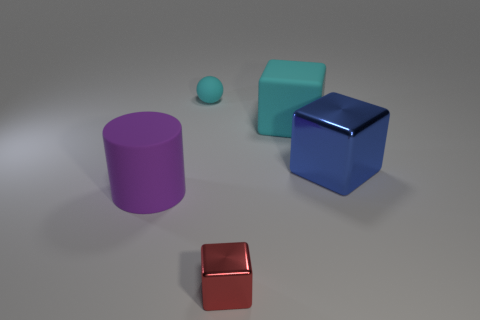Add 5 large shiny things. How many objects exist? 10 Subtract all spheres. How many objects are left? 4 Add 1 big blocks. How many big blocks are left? 3 Add 5 big brown shiny balls. How many big brown shiny balls exist? 5 Subtract 0 yellow cylinders. How many objects are left? 5 Subtract all small cyan balls. Subtract all small spheres. How many objects are left? 3 